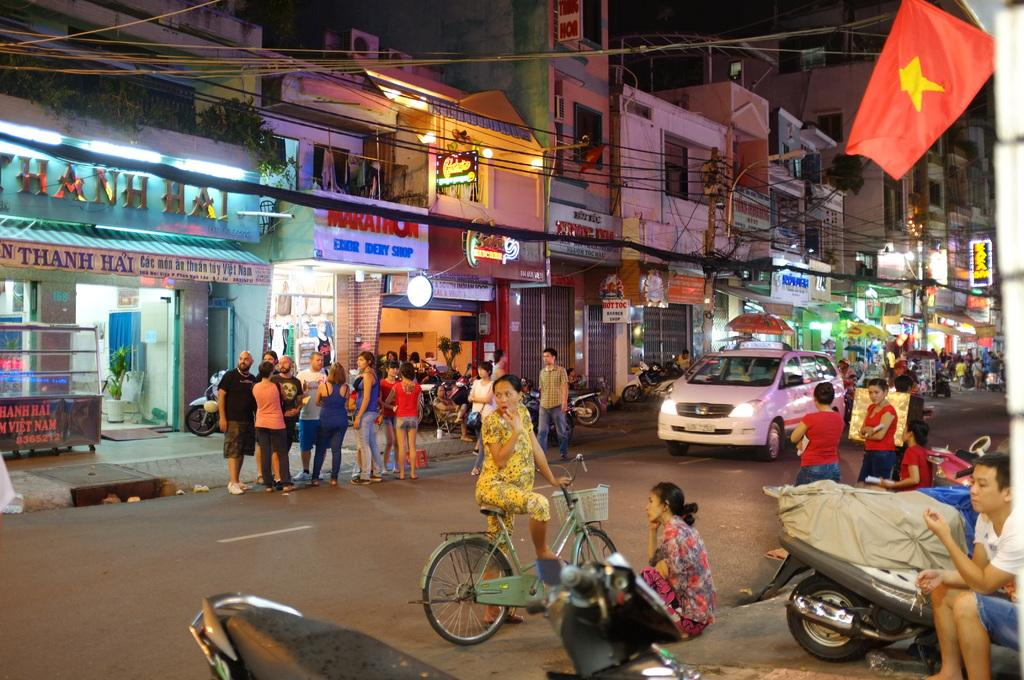Provide a one-sentence caption for the provided image. A group of people are gathered on the street in front of several stores, including Marathon Embr Idery Shop in Vietnam. 